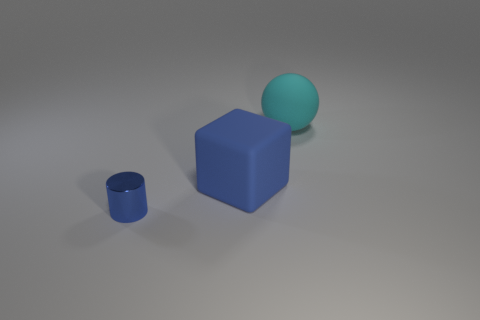There is a large block that is the same color as the tiny cylinder; what is its material?
Make the answer very short. Rubber. There is a blue thing that is behind the cylinder that is in front of the blue object right of the small blue thing; what size is it?
Ensure brevity in your answer.  Large. Is the number of big matte objects that are to the left of the small blue object greater than the number of small shiny cylinders to the right of the matte cube?
Offer a very short reply. No. What number of large matte things are behind the blue object behind the small thing?
Provide a short and direct response. 1. Is there another small metal cylinder that has the same color as the cylinder?
Provide a short and direct response. No. Is the size of the blue metal object the same as the rubber sphere?
Offer a terse response. No. Does the big rubber ball have the same color as the big block?
Ensure brevity in your answer.  No. The large object behind the blue thing behind the tiny metal cylinder is made of what material?
Offer a very short reply. Rubber. There is a blue object that is right of the blue metallic cylinder; is its size the same as the cylinder?
Ensure brevity in your answer.  No. What number of metallic things are either small purple cylinders or big blue objects?
Offer a terse response. 0. 